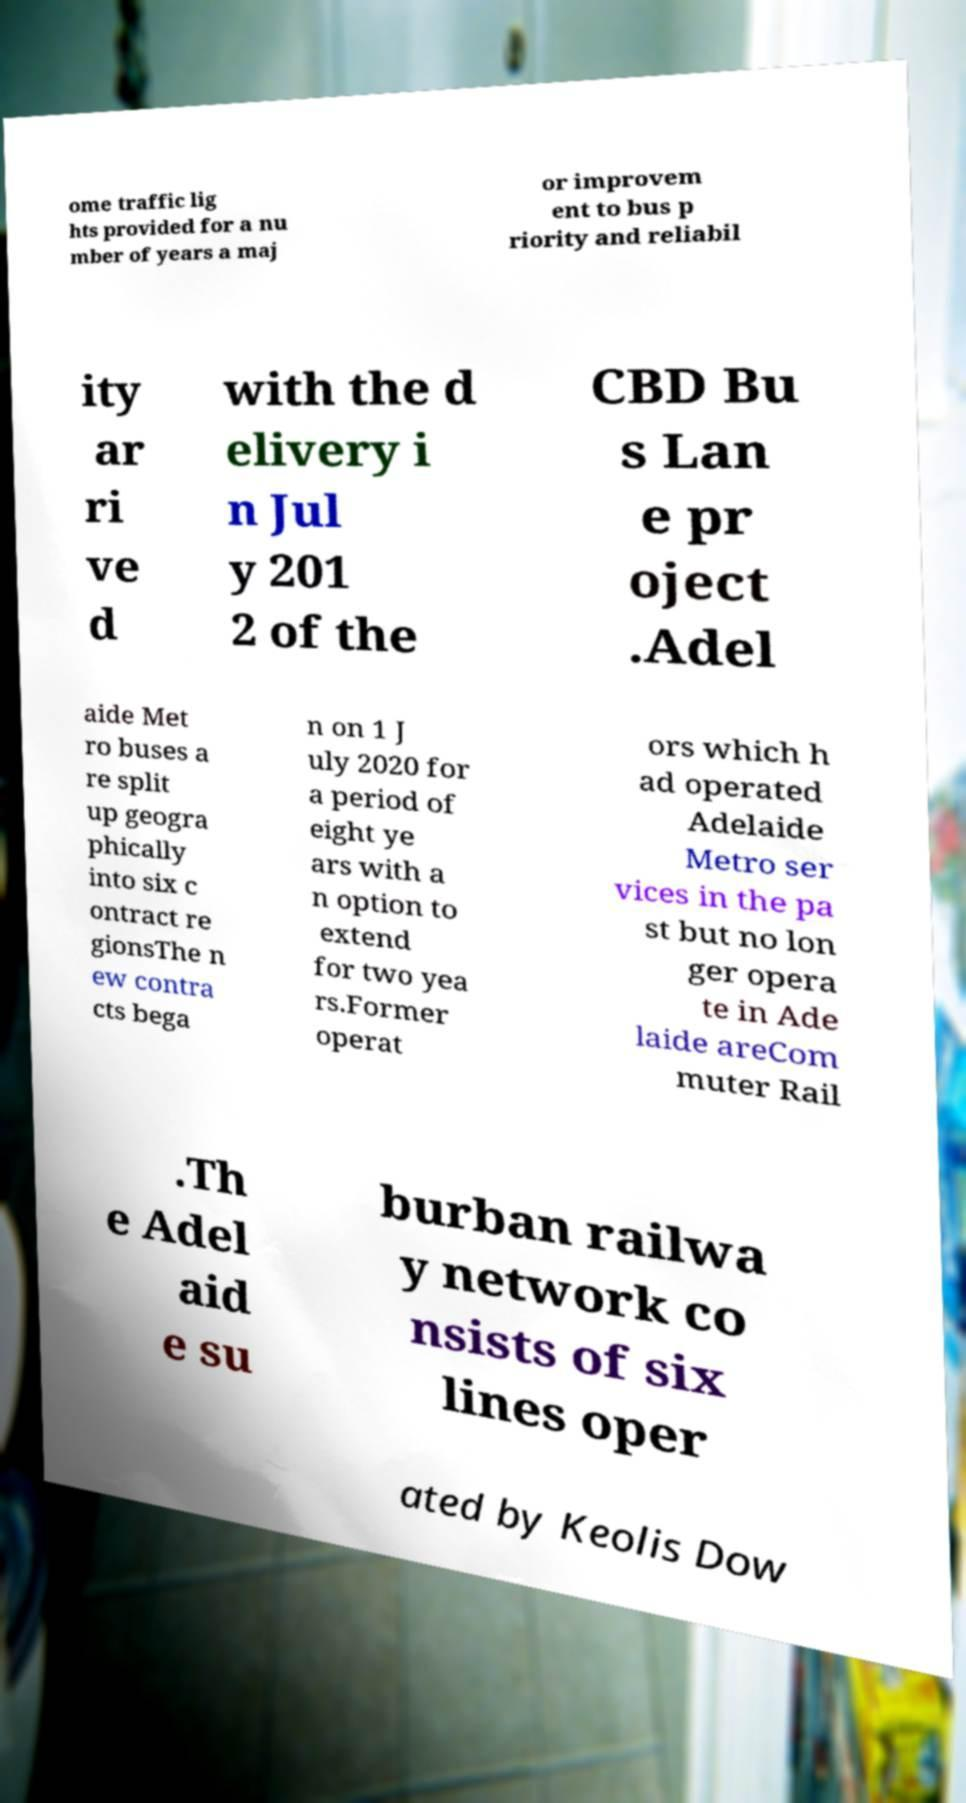Please read and relay the text visible in this image. What does it say? ome traffic lig hts provided for a nu mber of years a maj or improvem ent to bus p riority and reliabil ity ar ri ve d with the d elivery i n Jul y 201 2 of the CBD Bu s Lan e pr oject .Adel aide Met ro buses a re split up geogra phically into six c ontract re gionsThe n ew contra cts bega n on 1 J uly 2020 for a period of eight ye ars with a n option to extend for two yea rs.Former operat ors which h ad operated Adelaide Metro ser vices in the pa st but no lon ger opera te in Ade laide areCom muter Rail .Th e Adel aid e su burban railwa y network co nsists of six lines oper ated by Keolis Dow 